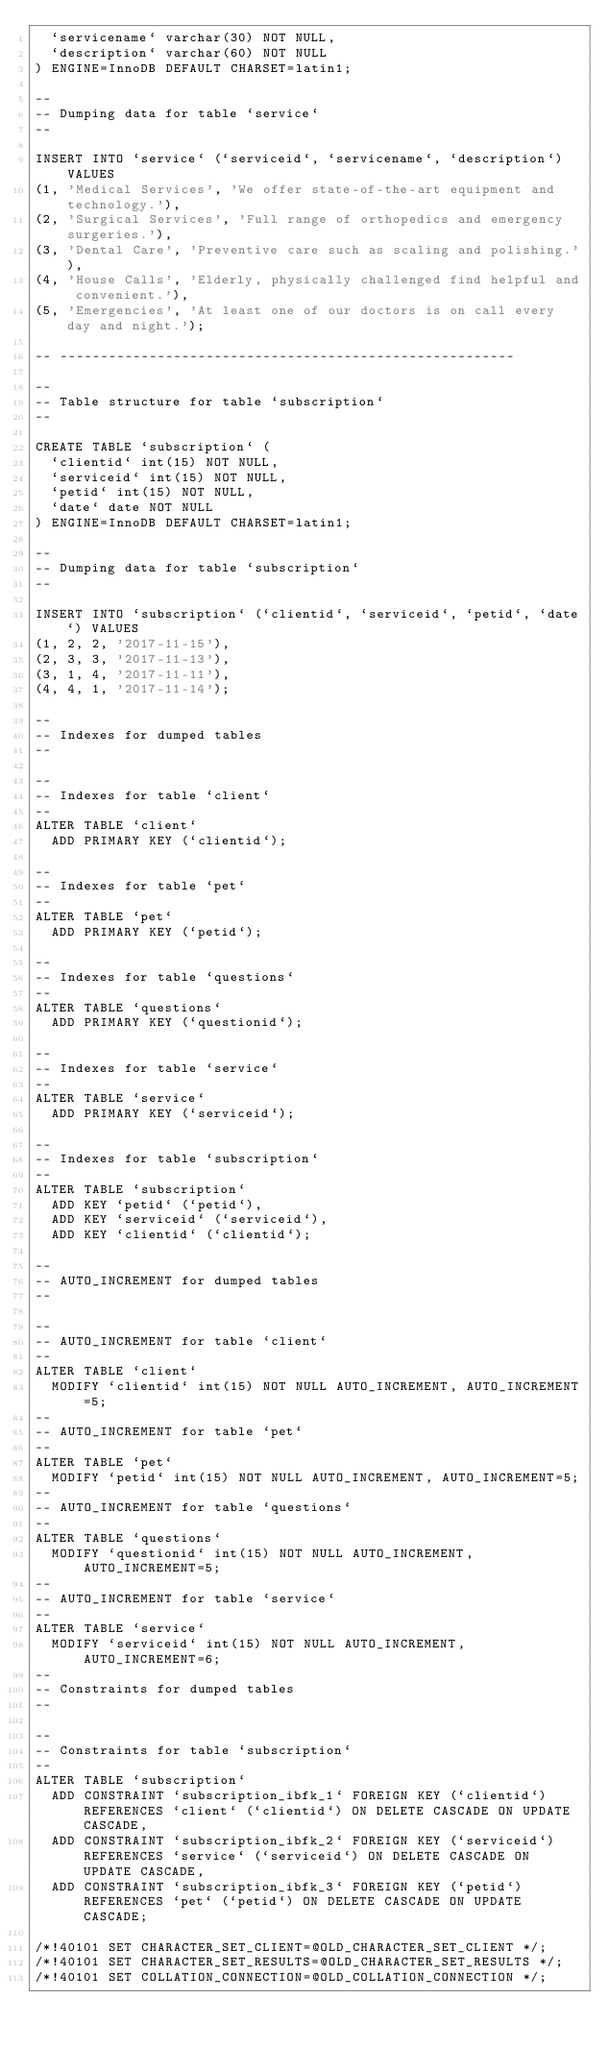<code> <loc_0><loc_0><loc_500><loc_500><_SQL_>  `servicename` varchar(30) NOT NULL,
  `description` varchar(60) NOT NULL
) ENGINE=InnoDB DEFAULT CHARSET=latin1;

--
-- Dumping data for table `service`
--

INSERT INTO `service` (`serviceid`, `servicename`, `description`) VALUES
(1, 'Medical Services', 'We offer state-of-the-art equipment and technology.'),
(2, 'Surgical Services', 'Full range of orthopedics and emergency surgeries.'),
(3, 'Dental Care', 'Preventive care such as scaling and polishing.'),
(4, 'House Calls', 'Elderly, physically challenged find helpful and convenient.'),
(5, 'Emergencies', 'At least one of our doctors is on call every day and night.');

-- --------------------------------------------------------

--
-- Table structure for table `subscription`
--

CREATE TABLE `subscription` (
  `clientid` int(15) NOT NULL,
  `serviceid` int(15) NOT NULL,
  `petid` int(15) NOT NULL,
  `date` date NOT NULL
) ENGINE=InnoDB DEFAULT CHARSET=latin1;

--
-- Dumping data for table `subscription`
--

INSERT INTO `subscription` (`clientid`, `serviceid`, `petid`, `date`) VALUES
(1, 2, 2, '2017-11-15'),
(2, 3, 3, '2017-11-13'),
(3, 1, 4, '2017-11-11'),
(4, 4, 1, '2017-11-14');

--
-- Indexes for dumped tables
--

--
-- Indexes for table `client`
--
ALTER TABLE `client`
  ADD PRIMARY KEY (`clientid`);

--
-- Indexes for table `pet`
--
ALTER TABLE `pet`
  ADD PRIMARY KEY (`petid`);

--
-- Indexes for table `questions`
--
ALTER TABLE `questions`
  ADD PRIMARY KEY (`questionid`);

--
-- Indexes for table `service`
--
ALTER TABLE `service`
  ADD PRIMARY KEY (`serviceid`);

--
-- Indexes for table `subscription`
--
ALTER TABLE `subscription`
  ADD KEY `petid` (`petid`),
  ADD KEY `serviceid` (`serviceid`),
  ADD KEY `clientid` (`clientid`);

--
-- AUTO_INCREMENT for dumped tables
--

--
-- AUTO_INCREMENT for table `client`
--
ALTER TABLE `client`
  MODIFY `clientid` int(15) NOT NULL AUTO_INCREMENT, AUTO_INCREMENT=5;
--
-- AUTO_INCREMENT for table `pet`
--
ALTER TABLE `pet`
  MODIFY `petid` int(15) NOT NULL AUTO_INCREMENT, AUTO_INCREMENT=5;
--
-- AUTO_INCREMENT for table `questions`
--
ALTER TABLE `questions`
  MODIFY `questionid` int(15) NOT NULL AUTO_INCREMENT, AUTO_INCREMENT=5;
--
-- AUTO_INCREMENT for table `service`
--
ALTER TABLE `service`
  MODIFY `serviceid` int(15) NOT NULL AUTO_INCREMENT, AUTO_INCREMENT=6;
--
-- Constraints for dumped tables
--

--
-- Constraints for table `subscription`
--
ALTER TABLE `subscription`
  ADD CONSTRAINT `subscription_ibfk_1` FOREIGN KEY (`clientid`) REFERENCES `client` (`clientid`) ON DELETE CASCADE ON UPDATE CASCADE,
  ADD CONSTRAINT `subscription_ibfk_2` FOREIGN KEY (`serviceid`) REFERENCES `service` (`serviceid`) ON DELETE CASCADE ON UPDATE CASCADE,
  ADD CONSTRAINT `subscription_ibfk_3` FOREIGN KEY (`petid`) REFERENCES `pet` (`petid`) ON DELETE CASCADE ON UPDATE CASCADE;

/*!40101 SET CHARACTER_SET_CLIENT=@OLD_CHARACTER_SET_CLIENT */;
/*!40101 SET CHARACTER_SET_RESULTS=@OLD_CHARACTER_SET_RESULTS */;
/*!40101 SET COLLATION_CONNECTION=@OLD_COLLATION_CONNECTION */;
</code> 